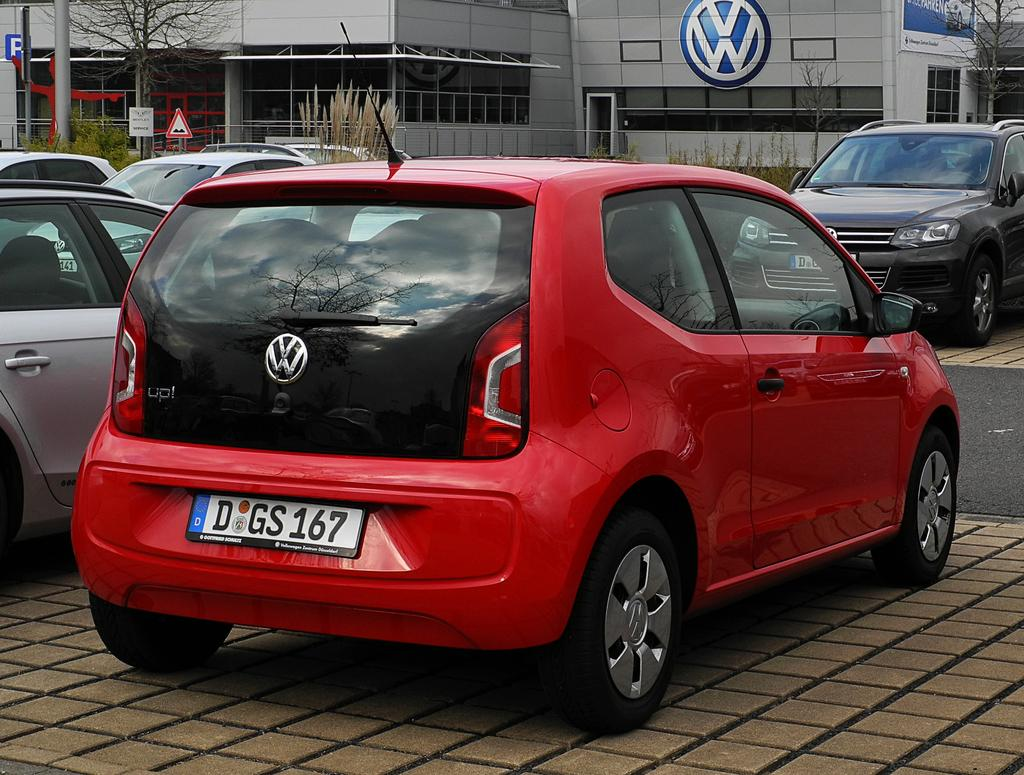What can be seen in the parking area in the image? There are cars parked in a parking area in the image. What is located in the background of the image? There is a car showroom in the background of the image. What type of natural elements are visible in the image? There are trees visible in the image. How many buckets of paint are needed to repaint the level of the wheel in the image? There are no buckets, levels, or wheels present in the image. 